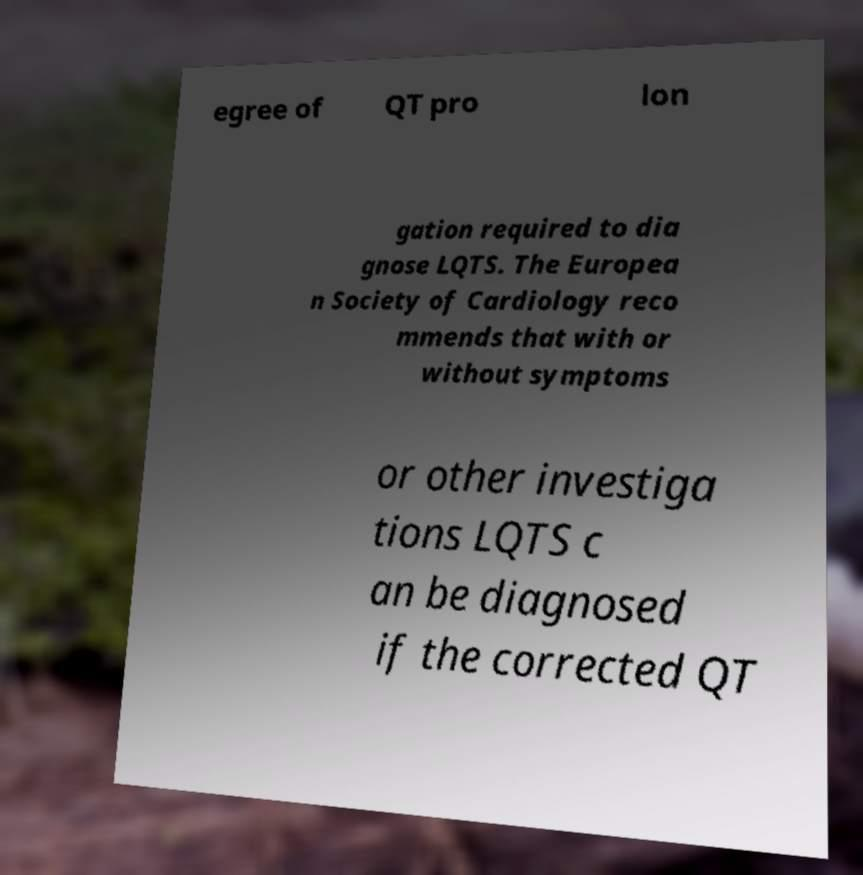There's text embedded in this image that I need extracted. Can you transcribe it verbatim? egree of QT pro lon gation required to dia gnose LQTS. The Europea n Society of Cardiology reco mmends that with or without symptoms or other investiga tions LQTS c an be diagnosed if the corrected QT 